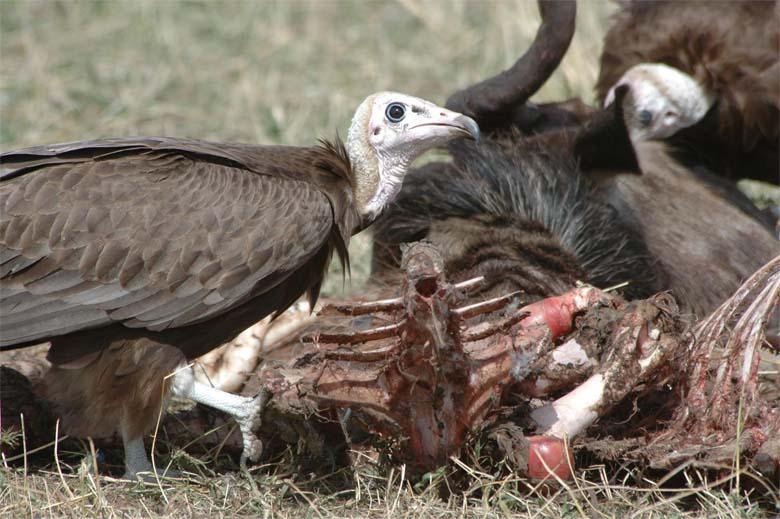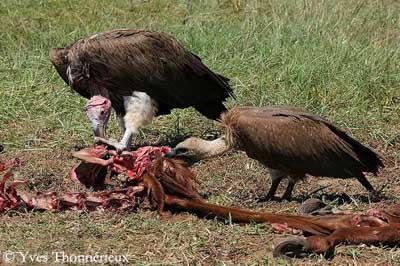The first image is the image on the left, the second image is the image on the right. Considering the images on both sides, is "At the center of the image there are at least two vultures picking over the carcass of a deceased animal." valid? Answer yes or no. Yes. The first image is the image on the left, the second image is the image on the right. For the images displayed, is the sentence "Vultures ripping flesh off of bones can be seen in one image." factually correct? Answer yes or no. Yes. 